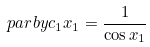Convert formula to latex. <formula><loc_0><loc_0><loc_500><loc_500>\ p a r b y { c _ { 1 } } { x _ { 1 } } & = \frac { 1 } { \cos x _ { 1 } }</formula> 